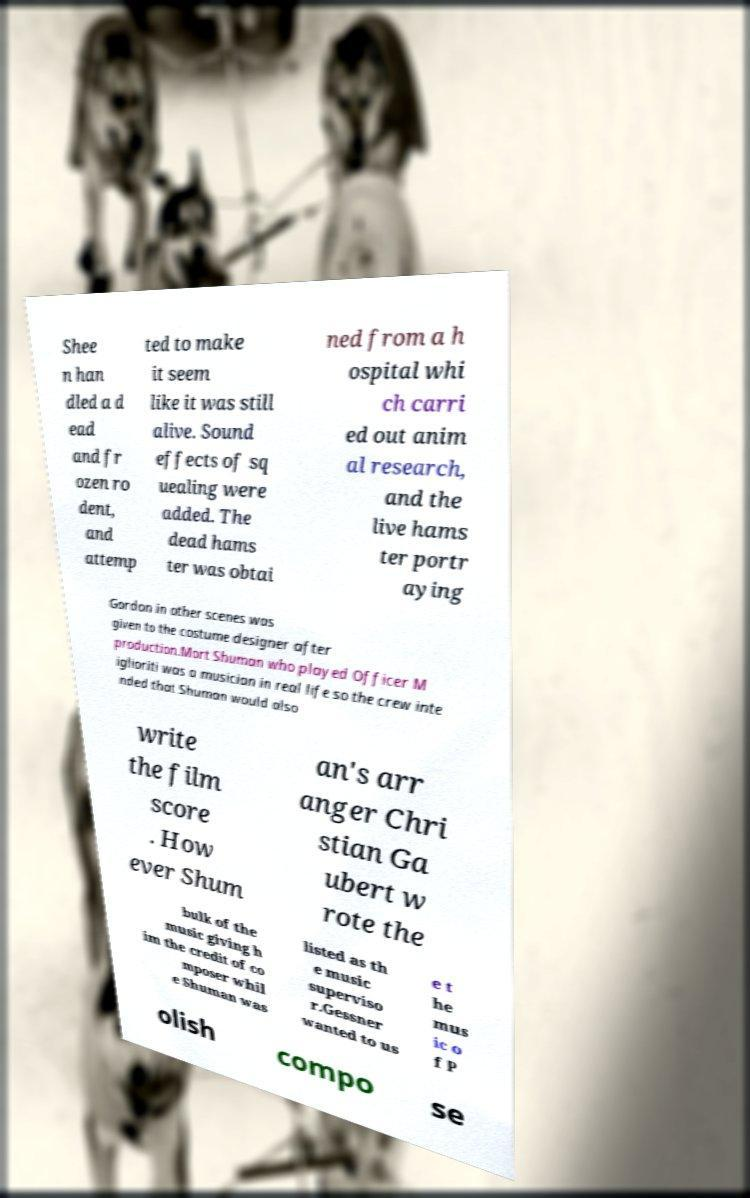There's text embedded in this image that I need extracted. Can you transcribe it verbatim? Shee n han dled a d ead and fr ozen ro dent, and attemp ted to make it seem like it was still alive. Sound effects of sq uealing were added. The dead hams ter was obtai ned from a h ospital whi ch carri ed out anim al research, and the live hams ter portr aying Gordon in other scenes was given to the costume designer after production.Mort Shuman who played Officer M iglioriti was a musician in real life so the crew inte nded that Shuman would also write the film score . How ever Shum an's arr anger Chri stian Ga ubert w rote the bulk of the music giving h im the credit of co mposer whil e Shuman was listed as th e music superviso r.Gessner wanted to us e t he mus ic o f P olish compo se 